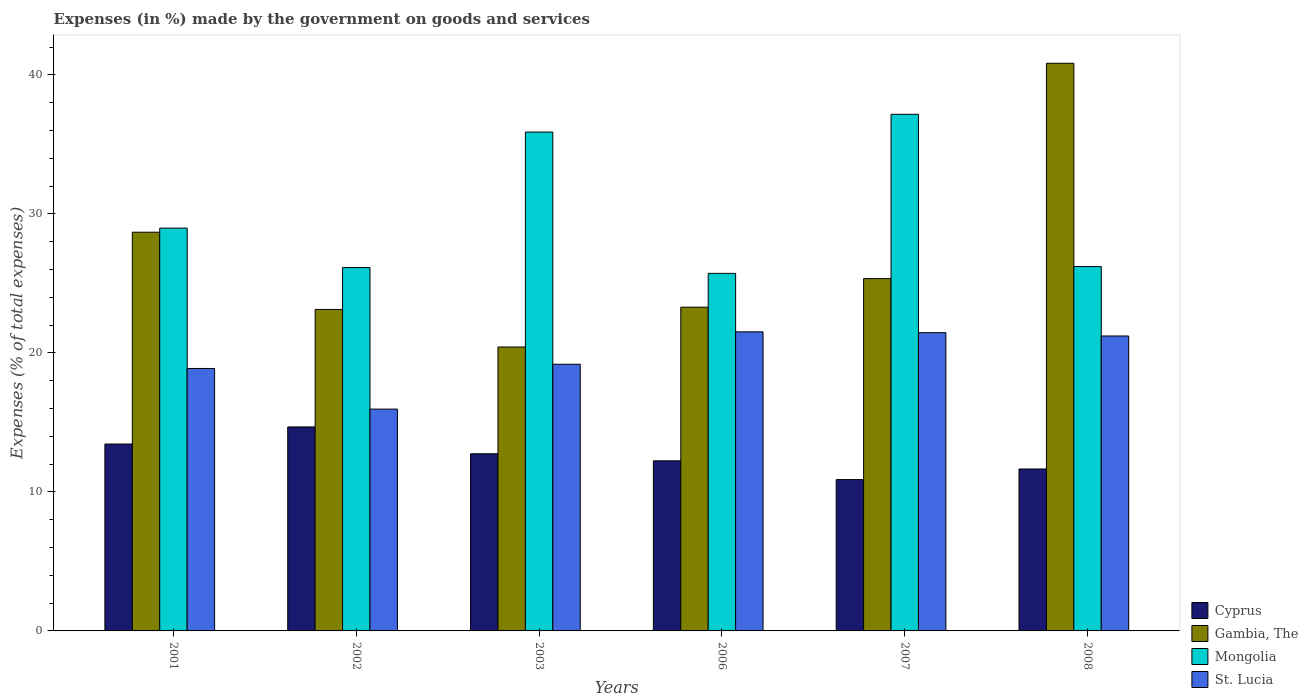How many groups of bars are there?
Your answer should be very brief. 6. Are the number of bars on each tick of the X-axis equal?
Your answer should be compact. Yes. How many bars are there on the 5th tick from the left?
Provide a succinct answer. 4. What is the percentage of expenses made by the government on goods and services in Gambia, The in 2001?
Keep it short and to the point. 28.68. Across all years, what is the maximum percentage of expenses made by the government on goods and services in St. Lucia?
Offer a terse response. 21.51. Across all years, what is the minimum percentage of expenses made by the government on goods and services in Cyprus?
Ensure brevity in your answer.  10.89. What is the total percentage of expenses made by the government on goods and services in Cyprus in the graph?
Your response must be concise. 75.63. What is the difference between the percentage of expenses made by the government on goods and services in Mongolia in 2002 and that in 2006?
Make the answer very short. 0.42. What is the difference between the percentage of expenses made by the government on goods and services in Cyprus in 2001 and the percentage of expenses made by the government on goods and services in Mongolia in 2002?
Provide a succinct answer. -12.69. What is the average percentage of expenses made by the government on goods and services in Cyprus per year?
Provide a short and direct response. 12.6. In the year 2002, what is the difference between the percentage of expenses made by the government on goods and services in St. Lucia and percentage of expenses made by the government on goods and services in Gambia, The?
Give a very brief answer. -7.17. In how many years, is the percentage of expenses made by the government on goods and services in St. Lucia greater than 40 %?
Your response must be concise. 0. What is the ratio of the percentage of expenses made by the government on goods and services in Cyprus in 2002 to that in 2003?
Make the answer very short. 1.15. Is the percentage of expenses made by the government on goods and services in Cyprus in 2003 less than that in 2007?
Your answer should be very brief. No. Is the difference between the percentage of expenses made by the government on goods and services in St. Lucia in 2002 and 2008 greater than the difference between the percentage of expenses made by the government on goods and services in Gambia, The in 2002 and 2008?
Offer a very short reply. Yes. What is the difference between the highest and the second highest percentage of expenses made by the government on goods and services in Gambia, The?
Offer a very short reply. 12.15. What is the difference between the highest and the lowest percentage of expenses made by the government on goods and services in Gambia, The?
Give a very brief answer. 20.41. In how many years, is the percentage of expenses made by the government on goods and services in Gambia, The greater than the average percentage of expenses made by the government on goods and services in Gambia, The taken over all years?
Your answer should be compact. 2. Is the sum of the percentage of expenses made by the government on goods and services in St. Lucia in 2002 and 2007 greater than the maximum percentage of expenses made by the government on goods and services in Cyprus across all years?
Provide a short and direct response. Yes. Is it the case that in every year, the sum of the percentage of expenses made by the government on goods and services in St. Lucia and percentage of expenses made by the government on goods and services in Gambia, The is greater than the sum of percentage of expenses made by the government on goods and services in Mongolia and percentage of expenses made by the government on goods and services in Cyprus?
Your response must be concise. No. What does the 3rd bar from the left in 2006 represents?
Ensure brevity in your answer.  Mongolia. What does the 1st bar from the right in 2008 represents?
Make the answer very short. St. Lucia. How many bars are there?
Ensure brevity in your answer.  24. How many years are there in the graph?
Your response must be concise. 6. What is the difference between two consecutive major ticks on the Y-axis?
Give a very brief answer. 10. Does the graph contain grids?
Your answer should be compact. No. Where does the legend appear in the graph?
Provide a succinct answer. Bottom right. How many legend labels are there?
Your answer should be very brief. 4. What is the title of the graph?
Your answer should be very brief. Expenses (in %) made by the government on goods and services. Does "Finland" appear as one of the legend labels in the graph?
Your answer should be compact. No. What is the label or title of the Y-axis?
Your answer should be compact. Expenses (% of total expenses). What is the Expenses (% of total expenses) of Cyprus in 2001?
Ensure brevity in your answer.  13.44. What is the Expenses (% of total expenses) of Gambia, The in 2001?
Make the answer very short. 28.68. What is the Expenses (% of total expenses) in Mongolia in 2001?
Offer a terse response. 28.98. What is the Expenses (% of total expenses) in St. Lucia in 2001?
Your answer should be compact. 18.88. What is the Expenses (% of total expenses) of Cyprus in 2002?
Make the answer very short. 14.67. What is the Expenses (% of total expenses) in Gambia, The in 2002?
Ensure brevity in your answer.  23.12. What is the Expenses (% of total expenses) in Mongolia in 2002?
Make the answer very short. 26.14. What is the Expenses (% of total expenses) in St. Lucia in 2002?
Offer a terse response. 15.96. What is the Expenses (% of total expenses) of Cyprus in 2003?
Keep it short and to the point. 12.74. What is the Expenses (% of total expenses) of Gambia, The in 2003?
Make the answer very short. 20.42. What is the Expenses (% of total expenses) in Mongolia in 2003?
Provide a succinct answer. 35.88. What is the Expenses (% of total expenses) of St. Lucia in 2003?
Make the answer very short. 19.18. What is the Expenses (% of total expenses) of Cyprus in 2006?
Your answer should be compact. 12.24. What is the Expenses (% of total expenses) in Gambia, The in 2006?
Offer a very short reply. 23.29. What is the Expenses (% of total expenses) of Mongolia in 2006?
Provide a short and direct response. 25.72. What is the Expenses (% of total expenses) in St. Lucia in 2006?
Provide a short and direct response. 21.51. What is the Expenses (% of total expenses) in Cyprus in 2007?
Your answer should be compact. 10.89. What is the Expenses (% of total expenses) in Gambia, The in 2007?
Your answer should be compact. 25.34. What is the Expenses (% of total expenses) in Mongolia in 2007?
Your answer should be compact. 37.16. What is the Expenses (% of total expenses) of St. Lucia in 2007?
Offer a terse response. 21.46. What is the Expenses (% of total expenses) in Cyprus in 2008?
Your answer should be very brief. 11.65. What is the Expenses (% of total expenses) in Gambia, The in 2008?
Offer a terse response. 40.83. What is the Expenses (% of total expenses) of Mongolia in 2008?
Make the answer very short. 26.21. What is the Expenses (% of total expenses) in St. Lucia in 2008?
Give a very brief answer. 21.21. Across all years, what is the maximum Expenses (% of total expenses) of Cyprus?
Offer a terse response. 14.67. Across all years, what is the maximum Expenses (% of total expenses) of Gambia, The?
Give a very brief answer. 40.83. Across all years, what is the maximum Expenses (% of total expenses) of Mongolia?
Your answer should be very brief. 37.16. Across all years, what is the maximum Expenses (% of total expenses) in St. Lucia?
Provide a succinct answer. 21.51. Across all years, what is the minimum Expenses (% of total expenses) of Cyprus?
Make the answer very short. 10.89. Across all years, what is the minimum Expenses (% of total expenses) in Gambia, The?
Offer a terse response. 20.42. Across all years, what is the minimum Expenses (% of total expenses) in Mongolia?
Give a very brief answer. 25.72. Across all years, what is the minimum Expenses (% of total expenses) of St. Lucia?
Provide a short and direct response. 15.96. What is the total Expenses (% of total expenses) of Cyprus in the graph?
Your answer should be compact. 75.63. What is the total Expenses (% of total expenses) in Gambia, The in the graph?
Offer a terse response. 161.69. What is the total Expenses (% of total expenses) of Mongolia in the graph?
Keep it short and to the point. 180.09. What is the total Expenses (% of total expenses) of St. Lucia in the graph?
Make the answer very short. 118.2. What is the difference between the Expenses (% of total expenses) of Cyprus in 2001 and that in 2002?
Your response must be concise. -1.23. What is the difference between the Expenses (% of total expenses) in Gambia, The in 2001 and that in 2002?
Give a very brief answer. 5.56. What is the difference between the Expenses (% of total expenses) of Mongolia in 2001 and that in 2002?
Provide a succinct answer. 2.84. What is the difference between the Expenses (% of total expenses) of St. Lucia in 2001 and that in 2002?
Make the answer very short. 2.92. What is the difference between the Expenses (% of total expenses) of Cyprus in 2001 and that in 2003?
Keep it short and to the point. 0.7. What is the difference between the Expenses (% of total expenses) of Gambia, The in 2001 and that in 2003?
Your answer should be compact. 8.26. What is the difference between the Expenses (% of total expenses) in Mongolia in 2001 and that in 2003?
Make the answer very short. -6.91. What is the difference between the Expenses (% of total expenses) of St. Lucia in 2001 and that in 2003?
Give a very brief answer. -0.3. What is the difference between the Expenses (% of total expenses) of Cyprus in 2001 and that in 2006?
Your answer should be very brief. 1.21. What is the difference between the Expenses (% of total expenses) of Gambia, The in 2001 and that in 2006?
Offer a terse response. 5.39. What is the difference between the Expenses (% of total expenses) of Mongolia in 2001 and that in 2006?
Give a very brief answer. 3.26. What is the difference between the Expenses (% of total expenses) in St. Lucia in 2001 and that in 2006?
Your response must be concise. -2.64. What is the difference between the Expenses (% of total expenses) of Cyprus in 2001 and that in 2007?
Your answer should be very brief. 2.56. What is the difference between the Expenses (% of total expenses) in Gambia, The in 2001 and that in 2007?
Your answer should be compact. 3.34. What is the difference between the Expenses (% of total expenses) of Mongolia in 2001 and that in 2007?
Ensure brevity in your answer.  -8.19. What is the difference between the Expenses (% of total expenses) of St. Lucia in 2001 and that in 2007?
Provide a short and direct response. -2.58. What is the difference between the Expenses (% of total expenses) in Cyprus in 2001 and that in 2008?
Your answer should be compact. 1.8. What is the difference between the Expenses (% of total expenses) in Gambia, The in 2001 and that in 2008?
Make the answer very short. -12.15. What is the difference between the Expenses (% of total expenses) in Mongolia in 2001 and that in 2008?
Your answer should be compact. 2.77. What is the difference between the Expenses (% of total expenses) in St. Lucia in 2001 and that in 2008?
Offer a terse response. -2.34. What is the difference between the Expenses (% of total expenses) of Cyprus in 2002 and that in 2003?
Offer a terse response. 1.93. What is the difference between the Expenses (% of total expenses) in Gambia, The in 2002 and that in 2003?
Give a very brief answer. 2.7. What is the difference between the Expenses (% of total expenses) of Mongolia in 2002 and that in 2003?
Offer a very short reply. -9.75. What is the difference between the Expenses (% of total expenses) of St. Lucia in 2002 and that in 2003?
Offer a terse response. -3.23. What is the difference between the Expenses (% of total expenses) in Cyprus in 2002 and that in 2006?
Your answer should be very brief. 2.44. What is the difference between the Expenses (% of total expenses) of Gambia, The in 2002 and that in 2006?
Keep it short and to the point. -0.16. What is the difference between the Expenses (% of total expenses) of Mongolia in 2002 and that in 2006?
Offer a terse response. 0.42. What is the difference between the Expenses (% of total expenses) of St. Lucia in 2002 and that in 2006?
Your response must be concise. -5.56. What is the difference between the Expenses (% of total expenses) in Cyprus in 2002 and that in 2007?
Offer a terse response. 3.79. What is the difference between the Expenses (% of total expenses) of Gambia, The in 2002 and that in 2007?
Offer a very short reply. -2.22. What is the difference between the Expenses (% of total expenses) of Mongolia in 2002 and that in 2007?
Ensure brevity in your answer.  -11.03. What is the difference between the Expenses (% of total expenses) in St. Lucia in 2002 and that in 2007?
Your answer should be compact. -5.5. What is the difference between the Expenses (% of total expenses) of Cyprus in 2002 and that in 2008?
Your response must be concise. 3.03. What is the difference between the Expenses (% of total expenses) of Gambia, The in 2002 and that in 2008?
Offer a very short reply. -17.71. What is the difference between the Expenses (% of total expenses) in Mongolia in 2002 and that in 2008?
Your answer should be very brief. -0.07. What is the difference between the Expenses (% of total expenses) of St. Lucia in 2002 and that in 2008?
Offer a terse response. -5.26. What is the difference between the Expenses (% of total expenses) in Cyprus in 2003 and that in 2006?
Provide a succinct answer. 0.51. What is the difference between the Expenses (% of total expenses) of Gambia, The in 2003 and that in 2006?
Make the answer very short. -2.87. What is the difference between the Expenses (% of total expenses) of Mongolia in 2003 and that in 2006?
Your answer should be compact. 10.16. What is the difference between the Expenses (% of total expenses) of St. Lucia in 2003 and that in 2006?
Give a very brief answer. -2.33. What is the difference between the Expenses (% of total expenses) in Cyprus in 2003 and that in 2007?
Give a very brief answer. 1.86. What is the difference between the Expenses (% of total expenses) of Gambia, The in 2003 and that in 2007?
Provide a short and direct response. -4.92. What is the difference between the Expenses (% of total expenses) of Mongolia in 2003 and that in 2007?
Offer a terse response. -1.28. What is the difference between the Expenses (% of total expenses) in St. Lucia in 2003 and that in 2007?
Your answer should be very brief. -2.27. What is the difference between the Expenses (% of total expenses) in Cyprus in 2003 and that in 2008?
Make the answer very short. 1.09. What is the difference between the Expenses (% of total expenses) of Gambia, The in 2003 and that in 2008?
Keep it short and to the point. -20.41. What is the difference between the Expenses (% of total expenses) in Mongolia in 2003 and that in 2008?
Make the answer very short. 9.68. What is the difference between the Expenses (% of total expenses) in St. Lucia in 2003 and that in 2008?
Your response must be concise. -2.03. What is the difference between the Expenses (% of total expenses) of Cyprus in 2006 and that in 2007?
Make the answer very short. 1.35. What is the difference between the Expenses (% of total expenses) in Gambia, The in 2006 and that in 2007?
Offer a very short reply. -2.05. What is the difference between the Expenses (% of total expenses) of Mongolia in 2006 and that in 2007?
Your response must be concise. -11.44. What is the difference between the Expenses (% of total expenses) of St. Lucia in 2006 and that in 2007?
Make the answer very short. 0.06. What is the difference between the Expenses (% of total expenses) in Cyprus in 2006 and that in 2008?
Ensure brevity in your answer.  0.59. What is the difference between the Expenses (% of total expenses) of Gambia, The in 2006 and that in 2008?
Your answer should be compact. -17.55. What is the difference between the Expenses (% of total expenses) in Mongolia in 2006 and that in 2008?
Make the answer very short. -0.49. What is the difference between the Expenses (% of total expenses) in St. Lucia in 2006 and that in 2008?
Provide a short and direct response. 0.3. What is the difference between the Expenses (% of total expenses) of Cyprus in 2007 and that in 2008?
Give a very brief answer. -0.76. What is the difference between the Expenses (% of total expenses) in Gambia, The in 2007 and that in 2008?
Ensure brevity in your answer.  -15.49. What is the difference between the Expenses (% of total expenses) in Mongolia in 2007 and that in 2008?
Your answer should be compact. 10.95. What is the difference between the Expenses (% of total expenses) of St. Lucia in 2007 and that in 2008?
Offer a terse response. 0.24. What is the difference between the Expenses (% of total expenses) in Cyprus in 2001 and the Expenses (% of total expenses) in Gambia, The in 2002?
Provide a short and direct response. -9.68. What is the difference between the Expenses (% of total expenses) in Cyprus in 2001 and the Expenses (% of total expenses) in Mongolia in 2002?
Your answer should be compact. -12.69. What is the difference between the Expenses (% of total expenses) of Cyprus in 2001 and the Expenses (% of total expenses) of St. Lucia in 2002?
Your answer should be very brief. -2.51. What is the difference between the Expenses (% of total expenses) in Gambia, The in 2001 and the Expenses (% of total expenses) in Mongolia in 2002?
Your response must be concise. 2.54. What is the difference between the Expenses (% of total expenses) of Gambia, The in 2001 and the Expenses (% of total expenses) of St. Lucia in 2002?
Make the answer very short. 12.72. What is the difference between the Expenses (% of total expenses) in Mongolia in 2001 and the Expenses (% of total expenses) in St. Lucia in 2002?
Provide a short and direct response. 13.02. What is the difference between the Expenses (% of total expenses) in Cyprus in 2001 and the Expenses (% of total expenses) in Gambia, The in 2003?
Offer a terse response. -6.98. What is the difference between the Expenses (% of total expenses) in Cyprus in 2001 and the Expenses (% of total expenses) in Mongolia in 2003?
Your answer should be compact. -22.44. What is the difference between the Expenses (% of total expenses) of Cyprus in 2001 and the Expenses (% of total expenses) of St. Lucia in 2003?
Offer a terse response. -5.74. What is the difference between the Expenses (% of total expenses) of Gambia, The in 2001 and the Expenses (% of total expenses) of Mongolia in 2003?
Provide a succinct answer. -7.2. What is the difference between the Expenses (% of total expenses) of Gambia, The in 2001 and the Expenses (% of total expenses) of St. Lucia in 2003?
Ensure brevity in your answer.  9.5. What is the difference between the Expenses (% of total expenses) of Mongolia in 2001 and the Expenses (% of total expenses) of St. Lucia in 2003?
Ensure brevity in your answer.  9.79. What is the difference between the Expenses (% of total expenses) of Cyprus in 2001 and the Expenses (% of total expenses) of Gambia, The in 2006?
Provide a succinct answer. -9.84. What is the difference between the Expenses (% of total expenses) in Cyprus in 2001 and the Expenses (% of total expenses) in Mongolia in 2006?
Offer a very short reply. -12.28. What is the difference between the Expenses (% of total expenses) of Cyprus in 2001 and the Expenses (% of total expenses) of St. Lucia in 2006?
Give a very brief answer. -8.07. What is the difference between the Expenses (% of total expenses) of Gambia, The in 2001 and the Expenses (% of total expenses) of Mongolia in 2006?
Provide a short and direct response. 2.96. What is the difference between the Expenses (% of total expenses) of Gambia, The in 2001 and the Expenses (% of total expenses) of St. Lucia in 2006?
Your answer should be very brief. 7.17. What is the difference between the Expenses (% of total expenses) of Mongolia in 2001 and the Expenses (% of total expenses) of St. Lucia in 2006?
Make the answer very short. 7.46. What is the difference between the Expenses (% of total expenses) of Cyprus in 2001 and the Expenses (% of total expenses) of Gambia, The in 2007?
Give a very brief answer. -11.9. What is the difference between the Expenses (% of total expenses) of Cyprus in 2001 and the Expenses (% of total expenses) of Mongolia in 2007?
Ensure brevity in your answer.  -23.72. What is the difference between the Expenses (% of total expenses) in Cyprus in 2001 and the Expenses (% of total expenses) in St. Lucia in 2007?
Ensure brevity in your answer.  -8.01. What is the difference between the Expenses (% of total expenses) of Gambia, The in 2001 and the Expenses (% of total expenses) of Mongolia in 2007?
Your answer should be very brief. -8.48. What is the difference between the Expenses (% of total expenses) in Gambia, The in 2001 and the Expenses (% of total expenses) in St. Lucia in 2007?
Your answer should be very brief. 7.22. What is the difference between the Expenses (% of total expenses) of Mongolia in 2001 and the Expenses (% of total expenses) of St. Lucia in 2007?
Provide a short and direct response. 7.52. What is the difference between the Expenses (% of total expenses) of Cyprus in 2001 and the Expenses (% of total expenses) of Gambia, The in 2008?
Your response must be concise. -27.39. What is the difference between the Expenses (% of total expenses) in Cyprus in 2001 and the Expenses (% of total expenses) in Mongolia in 2008?
Offer a terse response. -12.77. What is the difference between the Expenses (% of total expenses) of Cyprus in 2001 and the Expenses (% of total expenses) of St. Lucia in 2008?
Keep it short and to the point. -7.77. What is the difference between the Expenses (% of total expenses) in Gambia, The in 2001 and the Expenses (% of total expenses) in Mongolia in 2008?
Provide a succinct answer. 2.47. What is the difference between the Expenses (% of total expenses) in Gambia, The in 2001 and the Expenses (% of total expenses) in St. Lucia in 2008?
Offer a terse response. 7.47. What is the difference between the Expenses (% of total expenses) in Mongolia in 2001 and the Expenses (% of total expenses) in St. Lucia in 2008?
Provide a succinct answer. 7.76. What is the difference between the Expenses (% of total expenses) in Cyprus in 2002 and the Expenses (% of total expenses) in Gambia, The in 2003?
Ensure brevity in your answer.  -5.75. What is the difference between the Expenses (% of total expenses) in Cyprus in 2002 and the Expenses (% of total expenses) in Mongolia in 2003?
Offer a very short reply. -21.21. What is the difference between the Expenses (% of total expenses) in Cyprus in 2002 and the Expenses (% of total expenses) in St. Lucia in 2003?
Provide a short and direct response. -4.51. What is the difference between the Expenses (% of total expenses) of Gambia, The in 2002 and the Expenses (% of total expenses) of Mongolia in 2003?
Offer a very short reply. -12.76. What is the difference between the Expenses (% of total expenses) of Gambia, The in 2002 and the Expenses (% of total expenses) of St. Lucia in 2003?
Provide a short and direct response. 3.94. What is the difference between the Expenses (% of total expenses) of Mongolia in 2002 and the Expenses (% of total expenses) of St. Lucia in 2003?
Offer a very short reply. 6.96. What is the difference between the Expenses (% of total expenses) in Cyprus in 2002 and the Expenses (% of total expenses) in Gambia, The in 2006?
Ensure brevity in your answer.  -8.61. What is the difference between the Expenses (% of total expenses) in Cyprus in 2002 and the Expenses (% of total expenses) in Mongolia in 2006?
Provide a short and direct response. -11.05. What is the difference between the Expenses (% of total expenses) in Cyprus in 2002 and the Expenses (% of total expenses) in St. Lucia in 2006?
Offer a terse response. -6.84. What is the difference between the Expenses (% of total expenses) of Gambia, The in 2002 and the Expenses (% of total expenses) of Mongolia in 2006?
Ensure brevity in your answer.  -2.6. What is the difference between the Expenses (% of total expenses) of Gambia, The in 2002 and the Expenses (% of total expenses) of St. Lucia in 2006?
Your response must be concise. 1.61. What is the difference between the Expenses (% of total expenses) of Mongolia in 2002 and the Expenses (% of total expenses) of St. Lucia in 2006?
Make the answer very short. 4.62. What is the difference between the Expenses (% of total expenses) of Cyprus in 2002 and the Expenses (% of total expenses) of Gambia, The in 2007?
Keep it short and to the point. -10.67. What is the difference between the Expenses (% of total expenses) in Cyprus in 2002 and the Expenses (% of total expenses) in Mongolia in 2007?
Keep it short and to the point. -22.49. What is the difference between the Expenses (% of total expenses) in Cyprus in 2002 and the Expenses (% of total expenses) in St. Lucia in 2007?
Provide a short and direct response. -6.78. What is the difference between the Expenses (% of total expenses) in Gambia, The in 2002 and the Expenses (% of total expenses) in Mongolia in 2007?
Ensure brevity in your answer.  -14.04. What is the difference between the Expenses (% of total expenses) of Gambia, The in 2002 and the Expenses (% of total expenses) of St. Lucia in 2007?
Your answer should be compact. 1.67. What is the difference between the Expenses (% of total expenses) in Mongolia in 2002 and the Expenses (% of total expenses) in St. Lucia in 2007?
Provide a short and direct response. 4.68. What is the difference between the Expenses (% of total expenses) of Cyprus in 2002 and the Expenses (% of total expenses) of Gambia, The in 2008?
Your answer should be compact. -26.16. What is the difference between the Expenses (% of total expenses) of Cyprus in 2002 and the Expenses (% of total expenses) of Mongolia in 2008?
Ensure brevity in your answer.  -11.54. What is the difference between the Expenses (% of total expenses) in Cyprus in 2002 and the Expenses (% of total expenses) in St. Lucia in 2008?
Offer a terse response. -6.54. What is the difference between the Expenses (% of total expenses) in Gambia, The in 2002 and the Expenses (% of total expenses) in Mongolia in 2008?
Offer a very short reply. -3.08. What is the difference between the Expenses (% of total expenses) of Gambia, The in 2002 and the Expenses (% of total expenses) of St. Lucia in 2008?
Your answer should be very brief. 1.91. What is the difference between the Expenses (% of total expenses) in Mongolia in 2002 and the Expenses (% of total expenses) in St. Lucia in 2008?
Offer a terse response. 4.92. What is the difference between the Expenses (% of total expenses) in Cyprus in 2003 and the Expenses (% of total expenses) in Gambia, The in 2006?
Offer a terse response. -10.55. What is the difference between the Expenses (% of total expenses) in Cyprus in 2003 and the Expenses (% of total expenses) in Mongolia in 2006?
Offer a terse response. -12.98. What is the difference between the Expenses (% of total expenses) of Cyprus in 2003 and the Expenses (% of total expenses) of St. Lucia in 2006?
Provide a short and direct response. -8.77. What is the difference between the Expenses (% of total expenses) in Gambia, The in 2003 and the Expenses (% of total expenses) in Mongolia in 2006?
Offer a terse response. -5.3. What is the difference between the Expenses (% of total expenses) in Gambia, The in 2003 and the Expenses (% of total expenses) in St. Lucia in 2006?
Your answer should be compact. -1.09. What is the difference between the Expenses (% of total expenses) in Mongolia in 2003 and the Expenses (% of total expenses) in St. Lucia in 2006?
Your answer should be compact. 14.37. What is the difference between the Expenses (% of total expenses) in Cyprus in 2003 and the Expenses (% of total expenses) in Gambia, The in 2007?
Provide a succinct answer. -12.6. What is the difference between the Expenses (% of total expenses) in Cyprus in 2003 and the Expenses (% of total expenses) in Mongolia in 2007?
Your answer should be compact. -24.42. What is the difference between the Expenses (% of total expenses) of Cyprus in 2003 and the Expenses (% of total expenses) of St. Lucia in 2007?
Offer a terse response. -8.71. What is the difference between the Expenses (% of total expenses) in Gambia, The in 2003 and the Expenses (% of total expenses) in Mongolia in 2007?
Offer a terse response. -16.74. What is the difference between the Expenses (% of total expenses) of Gambia, The in 2003 and the Expenses (% of total expenses) of St. Lucia in 2007?
Offer a very short reply. -1.03. What is the difference between the Expenses (% of total expenses) in Mongolia in 2003 and the Expenses (% of total expenses) in St. Lucia in 2007?
Offer a terse response. 14.43. What is the difference between the Expenses (% of total expenses) in Cyprus in 2003 and the Expenses (% of total expenses) in Gambia, The in 2008?
Provide a short and direct response. -28.09. What is the difference between the Expenses (% of total expenses) of Cyprus in 2003 and the Expenses (% of total expenses) of Mongolia in 2008?
Ensure brevity in your answer.  -13.47. What is the difference between the Expenses (% of total expenses) in Cyprus in 2003 and the Expenses (% of total expenses) in St. Lucia in 2008?
Give a very brief answer. -8.47. What is the difference between the Expenses (% of total expenses) in Gambia, The in 2003 and the Expenses (% of total expenses) in Mongolia in 2008?
Your answer should be compact. -5.79. What is the difference between the Expenses (% of total expenses) in Gambia, The in 2003 and the Expenses (% of total expenses) in St. Lucia in 2008?
Keep it short and to the point. -0.79. What is the difference between the Expenses (% of total expenses) in Mongolia in 2003 and the Expenses (% of total expenses) in St. Lucia in 2008?
Make the answer very short. 14.67. What is the difference between the Expenses (% of total expenses) in Cyprus in 2006 and the Expenses (% of total expenses) in Gambia, The in 2007?
Offer a very short reply. -13.11. What is the difference between the Expenses (% of total expenses) in Cyprus in 2006 and the Expenses (% of total expenses) in Mongolia in 2007?
Give a very brief answer. -24.93. What is the difference between the Expenses (% of total expenses) of Cyprus in 2006 and the Expenses (% of total expenses) of St. Lucia in 2007?
Provide a succinct answer. -9.22. What is the difference between the Expenses (% of total expenses) of Gambia, The in 2006 and the Expenses (% of total expenses) of Mongolia in 2007?
Offer a very short reply. -13.87. What is the difference between the Expenses (% of total expenses) of Gambia, The in 2006 and the Expenses (% of total expenses) of St. Lucia in 2007?
Give a very brief answer. 1.83. What is the difference between the Expenses (% of total expenses) in Mongolia in 2006 and the Expenses (% of total expenses) in St. Lucia in 2007?
Offer a terse response. 4.26. What is the difference between the Expenses (% of total expenses) in Cyprus in 2006 and the Expenses (% of total expenses) in Gambia, The in 2008?
Keep it short and to the point. -28.6. What is the difference between the Expenses (% of total expenses) of Cyprus in 2006 and the Expenses (% of total expenses) of Mongolia in 2008?
Provide a short and direct response. -13.97. What is the difference between the Expenses (% of total expenses) in Cyprus in 2006 and the Expenses (% of total expenses) in St. Lucia in 2008?
Provide a succinct answer. -8.98. What is the difference between the Expenses (% of total expenses) of Gambia, The in 2006 and the Expenses (% of total expenses) of Mongolia in 2008?
Make the answer very short. -2.92. What is the difference between the Expenses (% of total expenses) in Gambia, The in 2006 and the Expenses (% of total expenses) in St. Lucia in 2008?
Your answer should be compact. 2.07. What is the difference between the Expenses (% of total expenses) of Mongolia in 2006 and the Expenses (% of total expenses) of St. Lucia in 2008?
Your answer should be very brief. 4.51. What is the difference between the Expenses (% of total expenses) in Cyprus in 2007 and the Expenses (% of total expenses) in Gambia, The in 2008?
Provide a succinct answer. -29.95. What is the difference between the Expenses (% of total expenses) in Cyprus in 2007 and the Expenses (% of total expenses) in Mongolia in 2008?
Your answer should be very brief. -15.32. What is the difference between the Expenses (% of total expenses) of Cyprus in 2007 and the Expenses (% of total expenses) of St. Lucia in 2008?
Offer a terse response. -10.33. What is the difference between the Expenses (% of total expenses) of Gambia, The in 2007 and the Expenses (% of total expenses) of Mongolia in 2008?
Provide a short and direct response. -0.87. What is the difference between the Expenses (% of total expenses) of Gambia, The in 2007 and the Expenses (% of total expenses) of St. Lucia in 2008?
Offer a very short reply. 4.13. What is the difference between the Expenses (% of total expenses) in Mongolia in 2007 and the Expenses (% of total expenses) in St. Lucia in 2008?
Your answer should be compact. 15.95. What is the average Expenses (% of total expenses) of Cyprus per year?
Your answer should be very brief. 12.6. What is the average Expenses (% of total expenses) of Gambia, The per year?
Keep it short and to the point. 26.95. What is the average Expenses (% of total expenses) in Mongolia per year?
Your response must be concise. 30.01. What is the average Expenses (% of total expenses) of St. Lucia per year?
Offer a very short reply. 19.7. In the year 2001, what is the difference between the Expenses (% of total expenses) of Cyprus and Expenses (% of total expenses) of Gambia, The?
Offer a terse response. -15.24. In the year 2001, what is the difference between the Expenses (% of total expenses) of Cyprus and Expenses (% of total expenses) of Mongolia?
Offer a terse response. -15.53. In the year 2001, what is the difference between the Expenses (% of total expenses) in Cyprus and Expenses (% of total expenses) in St. Lucia?
Provide a short and direct response. -5.43. In the year 2001, what is the difference between the Expenses (% of total expenses) in Gambia, The and Expenses (% of total expenses) in Mongolia?
Make the answer very short. -0.3. In the year 2001, what is the difference between the Expenses (% of total expenses) in Gambia, The and Expenses (% of total expenses) in St. Lucia?
Provide a short and direct response. 9.8. In the year 2001, what is the difference between the Expenses (% of total expenses) of Mongolia and Expenses (% of total expenses) of St. Lucia?
Keep it short and to the point. 10.1. In the year 2002, what is the difference between the Expenses (% of total expenses) of Cyprus and Expenses (% of total expenses) of Gambia, The?
Your response must be concise. -8.45. In the year 2002, what is the difference between the Expenses (% of total expenses) in Cyprus and Expenses (% of total expenses) in Mongolia?
Your response must be concise. -11.46. In the year 2002, what is the difference between the Expenses (% of total expenses) of Cyprus and Expenses (% of total expenses) of St. Lucia?
Your answer should be compact. -1.28. In the year 2002, what is the difference between the Expenses (% of total expenses) in Gambia, The and Expenses (% of total expenses) in Mongolia?
Your answer should be very brief. -3.01. In the year 2002, what is the difference between the Expenses (% of total expenses) of Gambia, The and Expenses (% of total expenses) of St. Lucia?
Your answer should be very brief. 7.17. In the year 2002, what is the difference between the Expenses (% of total expenses) of Mongolia and Expenses (% of total expenses) of St. Lucia?
Your answer should be very brief. 10.18. In the year 2003, what is the difference between the Expenses (% of total expenses) of Cyprus and Expenses (% of total expenses) of Gambia, The?
Provide a succinct answer. -7.68. In the year 2003, what is the difference between the Expenses (% of total expenses) in Cyprus and Expenses (% of total expenses) in Mongolia?
Give a very brief answer. -23.14. In the year 2003, what is the difference between the Expenses (% of total expenses) of Cyprus and Expenses (% of total expenses) of St. Lucia?
Your answer should be very brief. -6.44. In the year 2003, what is the difference between the Expenses (% of total expenses) in Gambia, The and Expenses (% of total expenses) in Mongolia?
Your answer should be very brief. -15.46. In the year 2003, what is the difference between the Expenses (% of total expenses) of Gambia, The and Expenses (% of total expenses) of St. Lucia?
Offer a very short reply. 1.24. In the year 2003, what is the difference between the Expenses (% of total expenses) in Mongolia and Expenses (% of total expenses) in St. Lucia?
Keep it short and to the point. 16.7. In the year 2006, what is the difference between the Expenses (% of total expenses) in Cyprus and Expenses (% of total expenses) in Gambia, The?
Keep it short and to the point. -11.05. In the year 2006, what is the difference between the Expenses (% of total expenses) in Cyprus and Expenses (% of total expenses) in Mongolia?
Offer a very short reply. -13.48. In the year 2006, what is the difference between the Expenses (% of total expenses) of Cyprus and Expenses (% of total expenses) of St. Lucia?
Keep it short and to the point. -9.28. In the year 2006, what is the difference between the Expenses (% of total expenses) in Gambia, The and Expenses (% of total expenses) in Mongolia?
Keep it short and to the point. -2.43. In the year 2006, what is the difference between the Expenses (% of total expenses) of Gambia, The and Expenses (% of total expenses) of St. Lucia?
Give a very brief answer. 1.77. In the year 2006, what is the difference between the Expenses (% of total expenses) in Mongolia and Expenses (% of total expenses) in St. Lucia?
Ensure brevity in your answer.  4.21. In the year 2007, what is the difference between the Expenses (% of total expenses) in Cyprus and Expenses (% of total expenses) in Gambia, The?
Your answer should be compact. -14.46. In the year 2007, what is the difference between the Expenses (% of total expenses) in Cyprus and Expenses (% of total expenses) in Mongolia?
Your response must be concise. -26.28. In the year 2007, what is the difference between the Expenses (% of total expenses) of Cyprus and Expenses (% of total expenses) of St. Lucia?
Offer a terse response. -10.57. In the year 2007, what is the difference between the Expenses (% of total expenses) of Gambia, The and Expenses (% of total expenses) of Mongolia?
Your response must be concise. -11.82. In the year 2007, what is the difference between the Expenses (% of total expenses) in Gambia, The and Expenses (% of total expenses) in St. Lucia?
Provide a short and direct response. 3.89. In the year 2007, what is the difference between the Expenses (% of total expenses) in Mongolia and Expenses (% of total expenses) in St. Lucia?
Provide a succinct answer. 15.71. In the year 2008, what is the difference between the Expenses (% of total expenses) in Cyprus and Expenses (% of total expenses) in Gambia, The?
Your answer should be compact. -29.19. In the year 2008, what is the difference between the Expenses (% of total expenses) in Cyprus and Expenses (% of total expenses) in Mongolia?
Make the answer very short. -14.56. In the year 2008, what is the difference between the Expenses (% of total expenses) in Cyprus and Expenses (% of total expenses) in St. Lucia?
Offer a very short reply. -9.57. In the year 2008, what is the difference between the Expenses (% of total expenses) in Gambia, The and Expenses (% of total expenses) in Mongolia?
Offer a terse response. 14.62. In the year 2008, what is the difference between the Expenses (% of total expenses) of Gambia, The and Expenses (% of total expenses) of St. Lucia?
Make the answer very short. 19.62. In the year 2008, what is the difference between the Expenses (% of total expenses) in Mongolia and Expenses (% of total expenses) in St. Lucia?
Your answer should be very brief. 4.99. What is the ratio of the Expenses (% of total expenses) in Cyprus in 2001 to that in 2002?
Your answer should be very brief. 0.92. What is the ratio of the Expenses (% of total expenses) of Gambia, The in 2001 to that in 2002?
Provide a short and direct response. 1.24. What is the ratio of the Expenses (% of total expenses) of Mongolia in 2001 to that in 2002?
Provide a succinct answer. 1.11. What is the ratio of the Expenses (% of total expenses) in St. Lucia in 2001 to that in 2002?
Provide a short and direct response. 1.18. What is the ratio of the Expenses (% of total expenses) of Cyprus in 2001 to that in 2003?
Give a very brief answer. 1.05. What is the ratio of the Expenses (% of total expenses) of Gambia, The in 2001 to that in 2003?
Offer a terse response. 1.4. What is the ratio of the Expenses (% of total expenses) in Mongolia in 2001 to that in 2003?
Offer a very short reply. 0.81. What is the ratio of the Expenses (% of total expenses) of St. Lucia in 2001 to that in 2003?
Ensure brevity in your answer.  0.98. What is the ratio of the Expenses (% of total expenses) of Cyprus in 2001 to that in 2006?
Your answer should be very brief. 1.1. What is the ratio of the Expenses (% of total expenses) of Gambia, The in 2001 to that in 2006?
Your response must be concise. 1.23. What is the ratio of the Expenses (% of total expenses) of Mongolia in 2001 to that in 2006?
Your response must be concise. 1.13. What is the ratio of the Expenses (% of total expenses) of St. Lucia in 2001 to that in 2006?
Give a very brief answer. 0.88. What is the ratio of the Expenses (% of total expenses) of Cyprus in 2001 to that in 2007?
Your answer should be compact. 1.24. What is the ratio of the Expenses (% of total expenses) of Gambia, The in 2001 to that in 2007?
Your answer should be very brief. 1.13. What is the ratio of the Expenses (% of total expenses) of Mongolia in 2001 to that in 2007?
Your answer should be very brief. 0.78. What is the ratio of the Expenses (% of total expenses) of St. Lucia in 2001 to that in 2007?
Your answer should be compact. 0.88. What is the ratio of the Expenses (% of total expenses) in Cyprus in 2001 to that in 2008?
Provide a short and direct response. 1.15. What is the ratio of the Expenses (% of total expenses) of Gambia, The in 2001 to that in 2008?
Your answer should be compact. 0.7. What is the ratio of the Expenses (% of total expenses) of Mongolia in 2001 to that in 2008?
Make the answer very short. 1.11. What is the ratio of the Expenses (% of total expenses) in St. Lucia in 2001 to that in 2008?
Make the answer very short. 0.89. What is the ratio of the Expenses (% of total expenses) of Cyprus in 2002 to that in 2003?
Provide a succinct answer. 1.15. What is the ratio of the Expenses (% of total expenses) in Gambia, The in 2002 to that in 2003?
Make the answer very short. 1.13. What is the ratio of the Expenses (% of total expenses) of Mongolia in 2002 to that in 2003?
Keep it short and to the point. 0.73. What is the ratio of the Expenses (% of total expenses) of St. Lucia in 2002 to that in 2003?
Your response must be concise. 0.83. What is the ratio of the Expenses (% of total expenses) of Cyprus in 2002 to that in 2006?
Your answer should be compact. 1.2. What is the ratio of the Expenses (% of total expenses) in Gambia, The in 2002 to that in 2006?
Keep it short and to the point. 0.99. What is the ratio of the Expenses (% of total expenses) of Mongolia in 2002 to that in 2006?
Offer a very short reply. 1.02. What is the ratio of the Expenses (% of total expenses) in St. Lucia in 2002 to that in 2006?
Give a very brief answer. 0.74. What is the ratio of the Expenses (% of total expenses) of Cyprus in 2002 to that in 2007?
Your answer should be compact. 1.35. What is the ratio of the Expenses (% of total expenses) of Gambia, The in 2002 to that in 2007?
Your answer should be compact. 0.91. What is the ratio of the Expenses (% of total expenses) of Mongolia in 2002 to that in 2007?
Your answer should be compact. 0.7. What is the ratio of the Expenses (% of total expenses) of St. Lucia in 2002 to that in 2007?
Offer a terse response. 0.74. What is the ratio of the Expenses (% of total expenses) of Cyprus in 2002 to that in 2008?
Keep it short and to the point. 1.26. What is the ratio of the Expenses (% of total expenses) in Gambia, The in 2002 to that in 2008?
Provide a succinct answer. 0.57. What is the ratio of the Expenses (% of total expenses) of St. Lucia in 2002 to that in 2008?
Make the answer very short. 0.75. What is the ratio of the Expenses (% of total expenses) of Cyprus in 2003 to that in 2006?
Offer a very short reply. 1.04. What is the ratio of the Expenses (% of total expenses) in Gambia, The in 2003 to that in 2006?
Your answer should be very brief. 0.88. What is the ratio of the Expenses (% of total expenses) in Mongolia in 2003 to that in 2006?
Your response must be concise. 1.4. What is the ratio of the Expenses (% of total expenses) of St. Lucia in 2003 to that in 2006?
Give a very brief answer. 0.89. What is the ratio of the Expenses (% of total expenses) of Cyprus in 2003 to that in 2007?
Provide a succinct answer. 1.17. What is the ratio of the Expenses (% of total expenses) in Gambia, The in 2003 to that in 2007?
Your answer should be compact. 0.81. What is the ratio of the Expenses (% of total expenses) of Mongolia in 2003 to that in 2007?
Your response must be concise. 0.97. What is the ratio of the Expenses (% of total expenses) of St. Lucia in 2003 to that in 2007?
Give a very brief answer. 0.89. What is the ratio of the Expenses (% of total expenses) in Cyprus in 2003 to that in 2008?
Offer a very short reply. 1.09. What is the ratio of the Expenses (% of total expenses) in Gambia, The in 2003 to that in 2008?
Provide a succinct answer. 0.5. What is the ratio of the Expenses (% of total expenses) of Mongolia in 2003 to that in 2008?
Keep it short and to the point. 1.37. What is the ratio of the Expenses (% of total expenses) in St. Lucia in 2003 to that in 2008?
Your response must be concise. 0.9. What is the ratio of the Expenses (% of total expenses) in Cyprus in 2006 to that in 2007?
Provide a short and direct response. 1.12. What is the ratio of the Expenses (% of total expenses) in Gambia, The in 2006 to that in 2007?
Ensure brevity in your answer.  0.92. What is the ratio of the Expenses (% of total expenses) in Mongolia in 2006 to that in 2007?
Provide a short and direct response. 0.69. What is the ratio of the Expenses (% of total expenses) of St. Lucia in 2006 to that in 2007?
Your response must be concise. 1. What is the ratio of the Expenses (% of total expenses) in Cyprus in 2006 to that in 2008?
Offer a very short reply. 1.05. What is the ratio of the Expenses (% of total expenses) in Gambia, The in 2006 to that in 2008?
Your response must be concise. 0.57. What is the ratio of the Expenses (% of total expenses) of Mongolia in 2006 to that in 2008?
Make the answer very short. 0.98. What is the ratio of the Expenses (% of total expenses) of St. Lucia in 2006 to that in 2008?
Your answer should be very brief. 1.01. What is the ratio of the Expenses (% of total expenses) of Cyprus in 2007 to that in 2008?
Give a very brief answer. 0.93. What is the ratio of the Expenses (% of total expenses) of Gambia, The in 2007 to that in 2008?
Offer a very short reply. 0.62. What is the ratio of the Expenses (% of total expenses) of Mongolia in 2007 to that in 2008?
Give a very brief answer. 1.42. What is the ratio of the Expenses (% of total expenses) of St. Lucia in 2007 to that in 2008?
Provide a succinct answer. 1.01. What is the difference between the highest and the second highest Expenses (% of total expenses) of Cyprus?
Provide a short and direct response. 1.23. What is the difference between the highest and the second highest Expenses (% of total expenses) in Gambia, The?
Make the answer very short. 12.15. What is the difference between the highest and the second highest Expenses (% of total expenses) in Mongolia?
Make the answer very short. 1.28. What is the difference between the highest and the second highest Expenses (% of total expenses) in St. Lucia?
Offer a terse response. 0.06. What is the difference between the highest and the lowest Expenses (% of total expenses) in Cyprus?
Provide a short and direct response. 3.79. What is the difference between the highest and the lowest Expenses (% of total expenses) in Gambia, The?
Give a very brief answer. 20.41. What is the difference between the highest and the lowest Expenses (% of total expenses) of Mongolia?
Provide a succinct answer. 11.44. What is the difference between the highest and the lowest Expenses (% of total expenses) in St. Lucia?
Give a very brief answer. 5.56. 